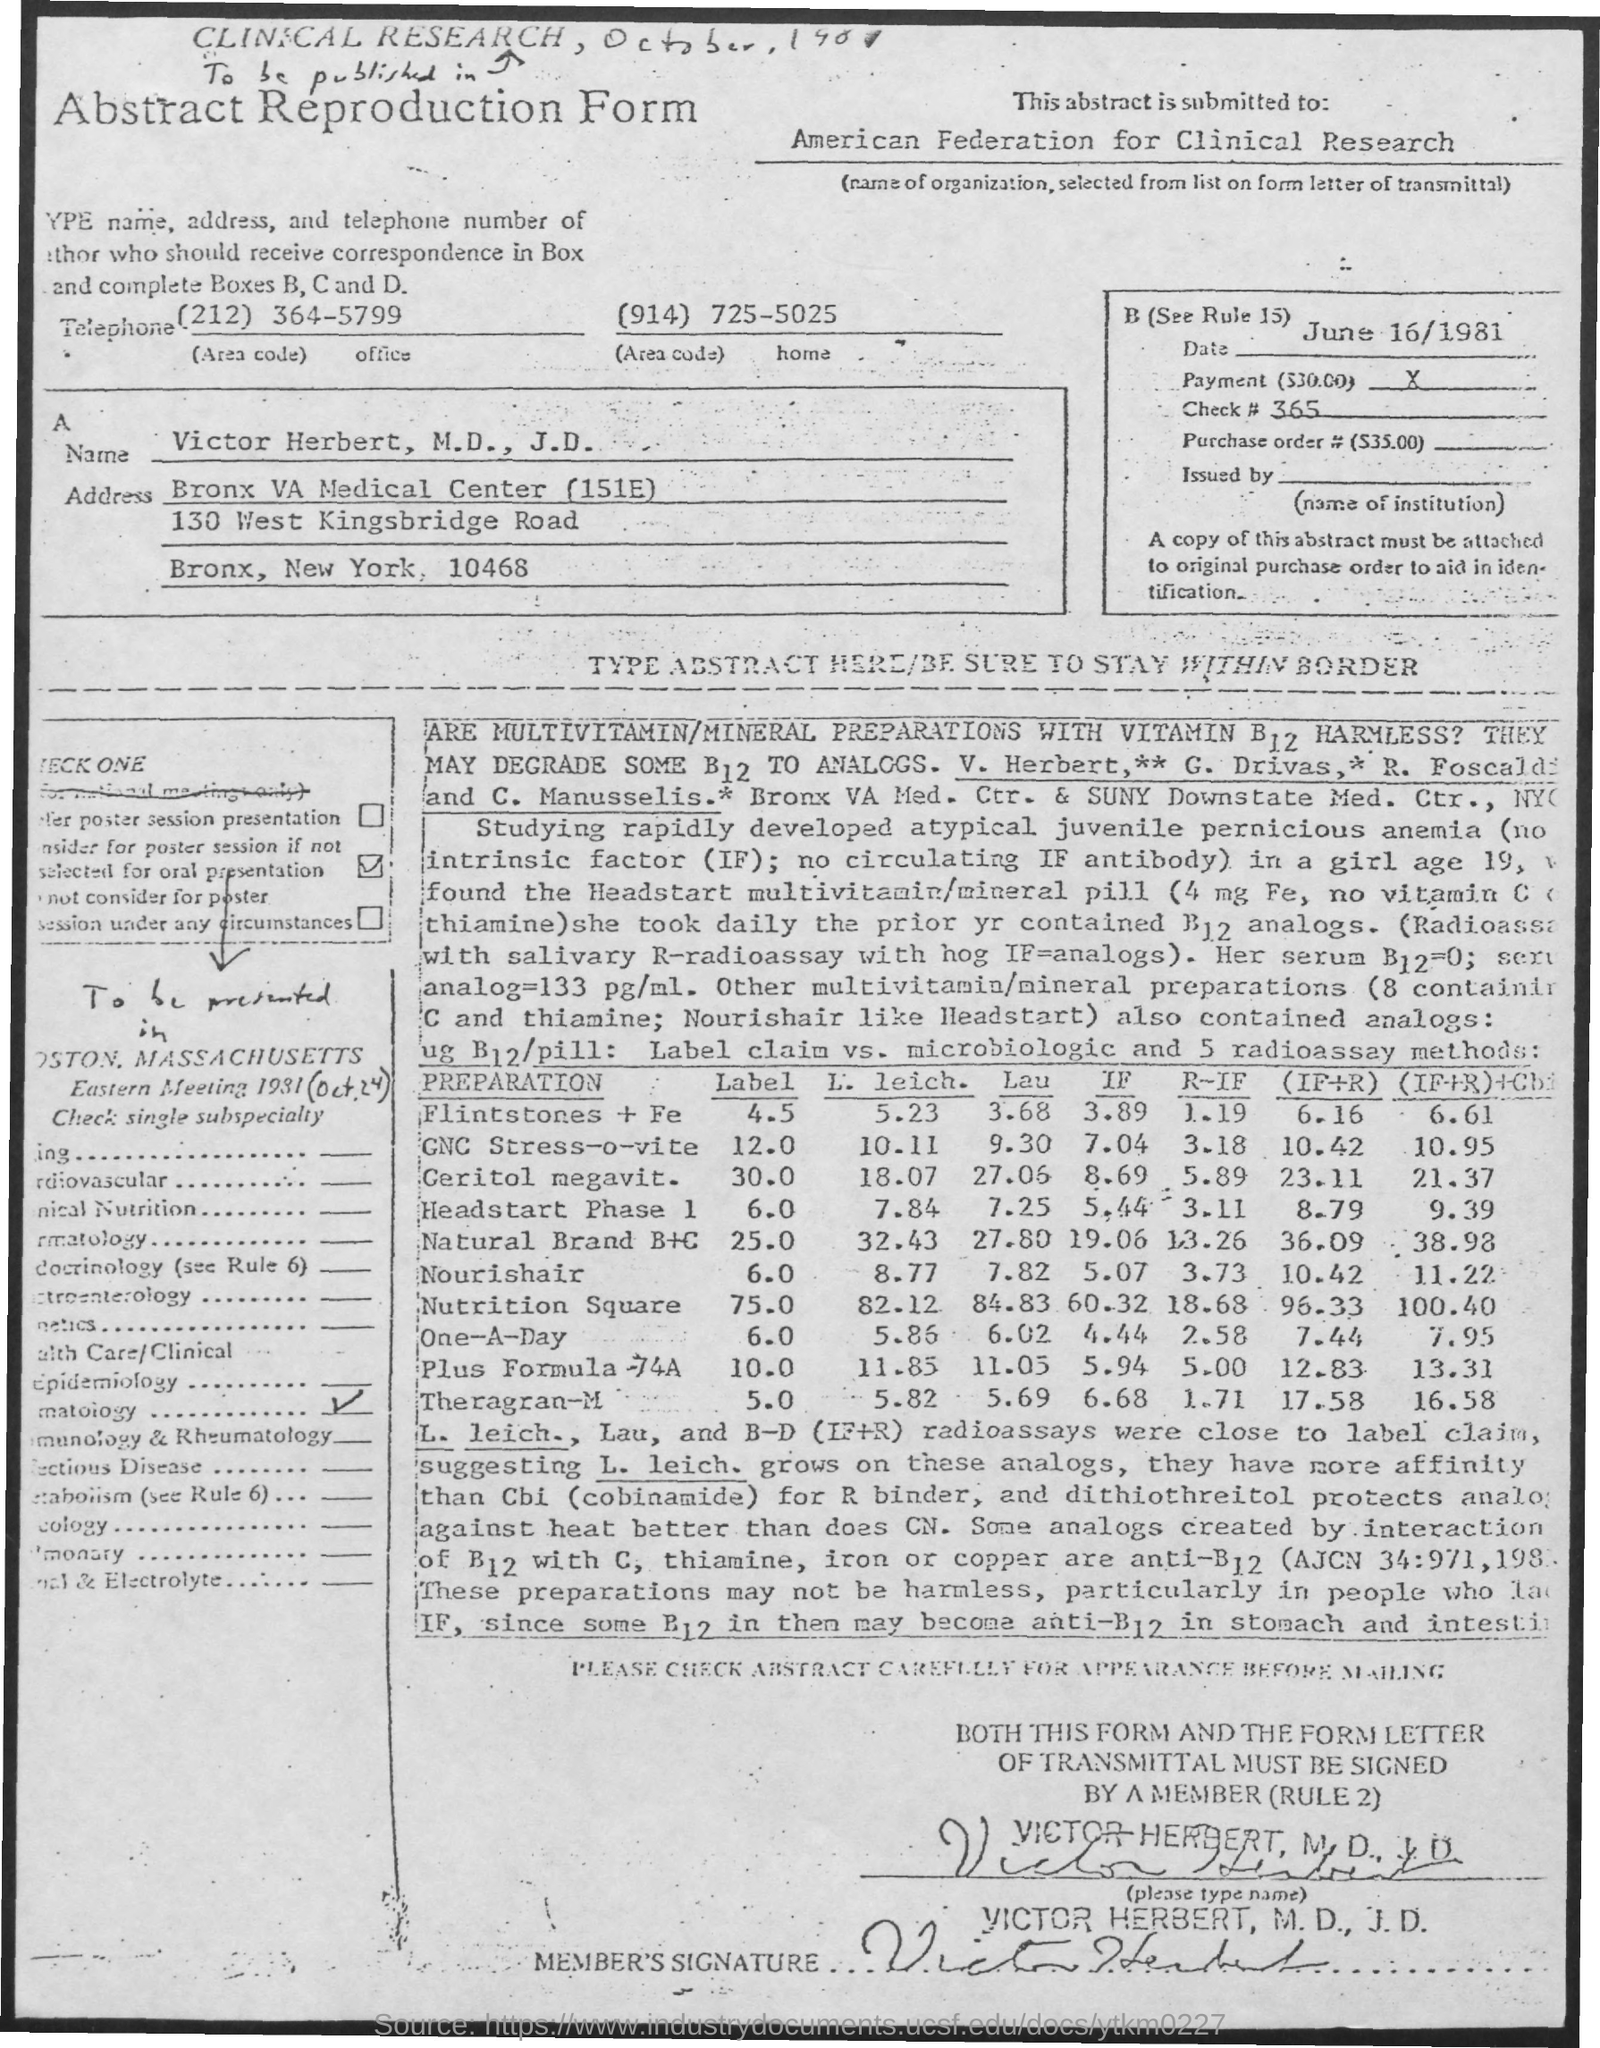Give some essential details in this illustration. The home telephone number is (914) 725-5025. The office telephone number is (212) 364-5799. The date on the document is June 16, 1981. This abstract is submitted to the American Federation for Clinical Research. The title of the document is 'Abstract Reproduction Form.' 